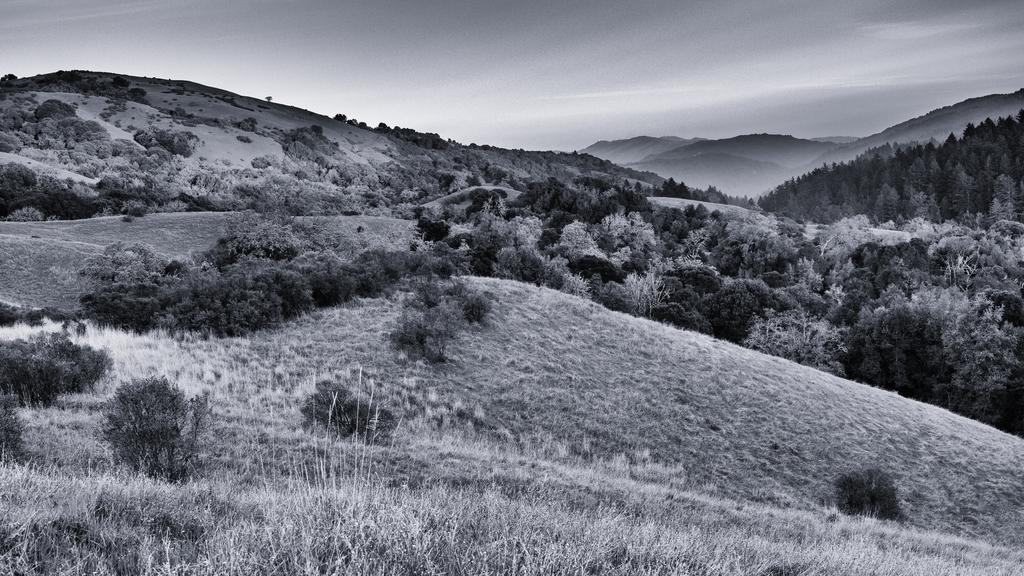What is the color scheme of the image? The picture is black and white. What type of vegetation can be seen in the image? There are plants, grass, and trees in the image. What geographical feature is present in the image? There are hills in the image. What part of the natural environment is visible in the image? The sky is visible in the image. What type of juice is being served at the family gathering in the image? There is no family gathering or juice present in the image; it features a black and white landscape with plants, grass, trees, hills, and a visible sky. 